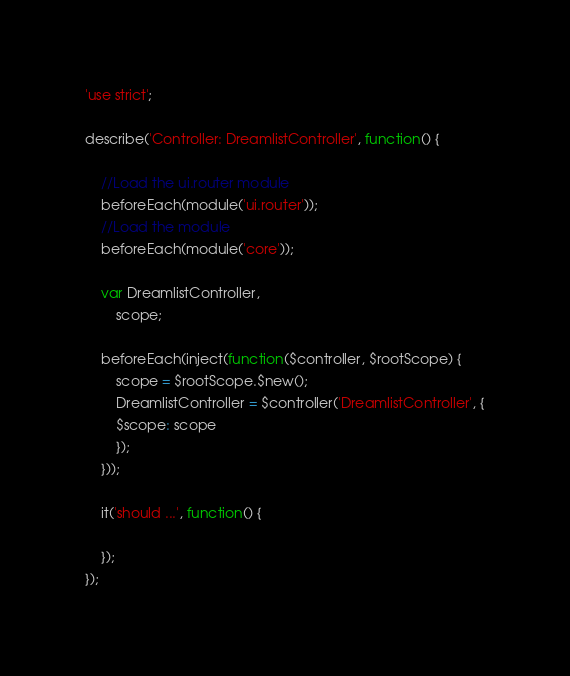Convert code to text. <code><loc_0><loc_0><loc_500><loc_500><_JavaScript_>'use strict';

describe('Controller: DreamlistController', function() {

    //Load the ui.router module
    beforeEach(module('ui.router'));
    //Load the module
    beforeEach(module('core'));

    var DreamlistController,
        scope;

    beforeEach(inject(function($controller, $rootScope) {
        scope = $rootScope.$new();
        DreamlistController = $controller('DreamlistController', {
        $scope: scope
        });
    }));

    it('should ...', function() {

    });
});
</code> 